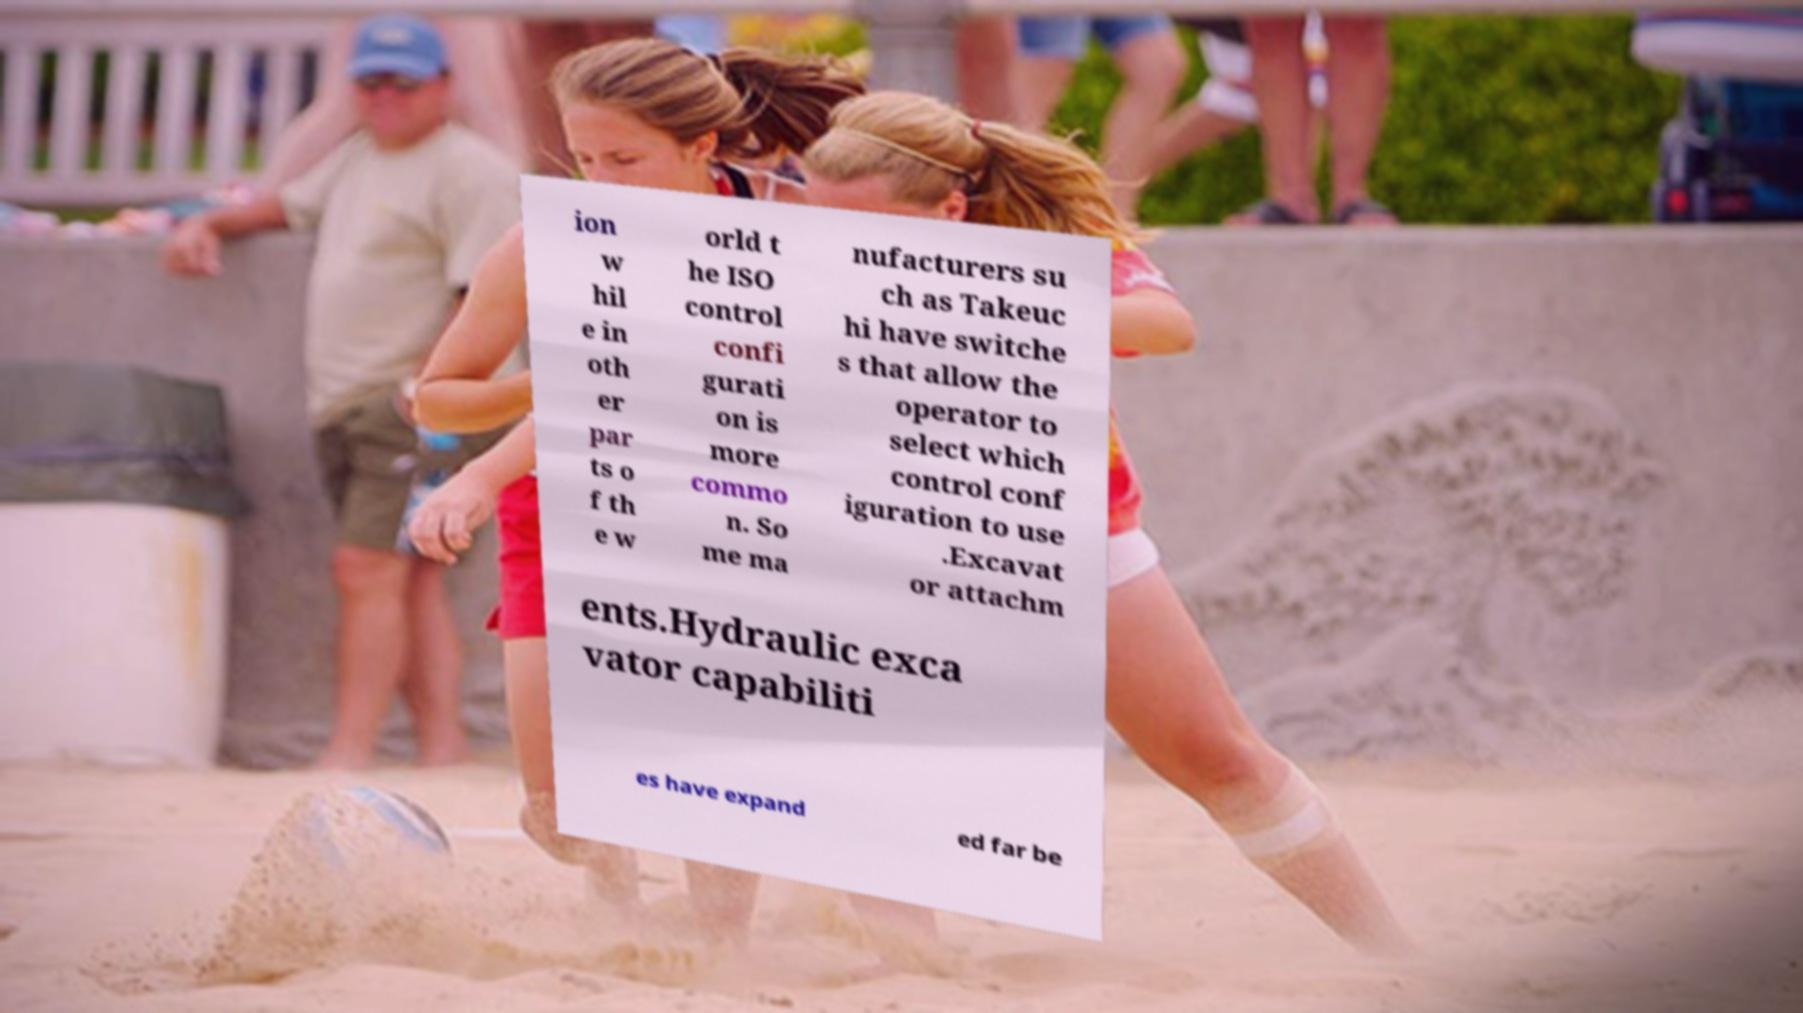For documentation purposes, I need the text within this image transcribed. Could you provide that? ion w hil e in oth er par ts o f th e w orld t he ISO control confi gurati on is more commo n. So me ma nufacturers su ch as Takeuc hi have switche s that allow the operator to select which control conf iguration to use .Excavat or attachm ents.Hydraulic exca vator capabiliti es have expand ed far be 